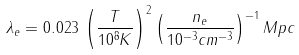Convert formula to latex. <formula><loc_0><loc_0><loc_500><loc_500>\lambda _ { e } = 0 . 0 2 3 \, \left ( \frac { T } { 1 0 ^ { 8 } K } \right ) ^ { 2 } \left ( \frac { n _ { e } } { 1 0 ^ { - 3 } c m ^ { - 3 } } \right ) ^ { - 1 } M p c</formula> 